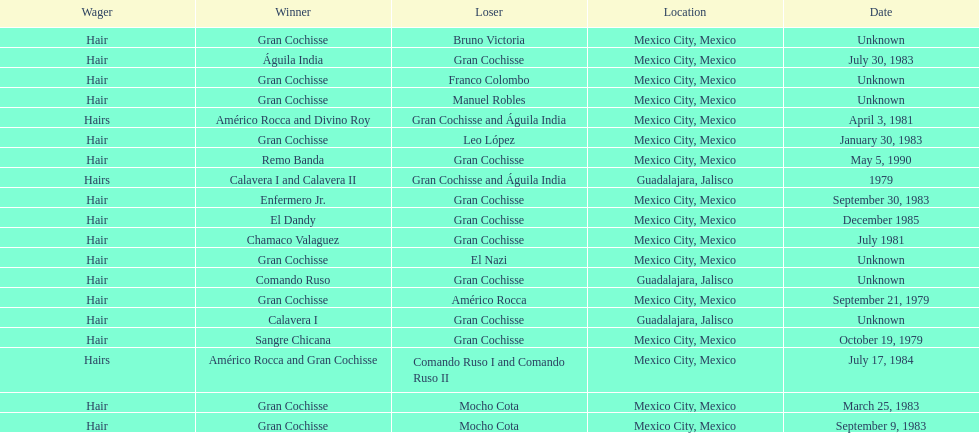Would you mind parsing the complete table? {'header': ['Wager', 'Winner', 'Loser', 'Location', 'Date'], 'rows': [['Hair', 'Gran Cochisse', 'Bruno Victoria', 'Mexico City, Mexico', 'Unknown'], ['Hair', 'Águila India', 'Gran Cochisse', 'Mexico City, Mexico', 'July 30, 1983'], ['Hair', 'Gran Cochisse', 'Franco Colombo', 'Mexico City, Mexico', 'Unknown'], ['Hair', 'Gran Cochisse', 'Manuel Robles', 'Mexico City, Mexico', 'Unknown'], ['Hairs', 'Américo Rocca and Divino Roy', 'Gran Cochisse and Águila India', 'Mexico City, Mexico', 'April 3, 1981'], ['Hair', 'Gran Cochisse', 'Leo López', 'Mexico City, Mexico', 'January 30, 1983'], ['Hair', 'Remo Banda', 'Gran Cochisse', 'Mexico City, Mexico', 'May 5, 1990'], ['Hairs', 'Calavera I and Calavera II', 'Gran Cochisse and Águila India', 'Guadalajara, Jalisco', '1979'], ['Hair', 'Enfermero Jr.', 'Gran Cochisse', 'Mexico City, Mexico', 'September 30, 1983'], ['Hair', 'El Dandy', 'Gran Cochisse', 'Mexico City, Mexico', 'December 1985'], ['Hair', 'Chamaco Valaguez', 'Gran Cochisse', 'Mexico City, Mexico', 'July 1981'], ['Hair', 'Gran Cochisse', 'El Nazi', 'Mexico City, Mexico', 'Unknown'], ['Hair', 'Comando Ruso', 'Gran Cochisse', 'Guadalajara, Jalisco', 'Unknown'], ['Hair', 'Gran Cochisse', 'Américo Rocca', 'Mexico City, Mexico', 'September 21, 1979'], ['Hair', 'Calavera I', 'Gran Cochisse', 'Guadalajara, Jalisco', 'Unknown'], ['Hair', 'Sangre Chicana', 'Gran Cochisse', 'Mexico City, Mexico', 'October 19, 1979'], ['Hairs', 'Américo Rocca and Gran Cochisse', 'Comando Ruso I and Comando Ruso II', 'Mexico City, Mexico', 'July 17, 1984'], ['Hair', 'Gran Cochisse', 'Mocho Cota', 'Mexico City, Mexico', 'March 25, 1983'], ['Hair', 'Gran Cochisse', 'Mocho Cota', 'Mexico City, Mexico', 'September 9, 1983']]} How many times did gran cochisse lose to el dandy? 1. 